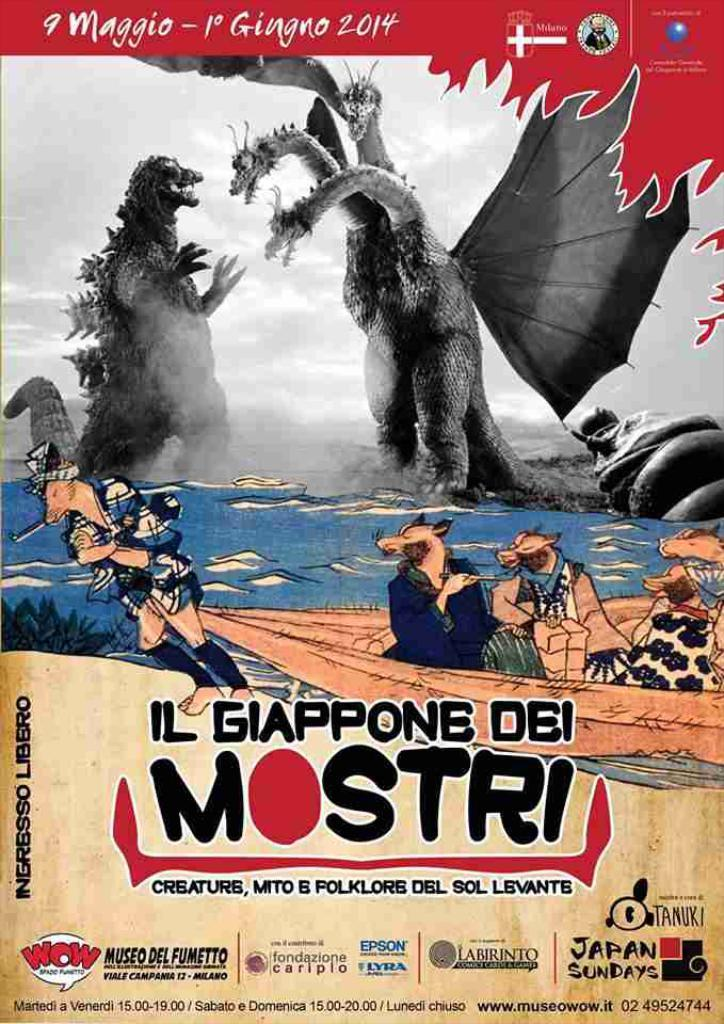<image>
Give a short and clear explanation of the subsequent image. A movie poster in Italian featuring two giant monsters facing off from Museo Del Fumetto in Milano. 